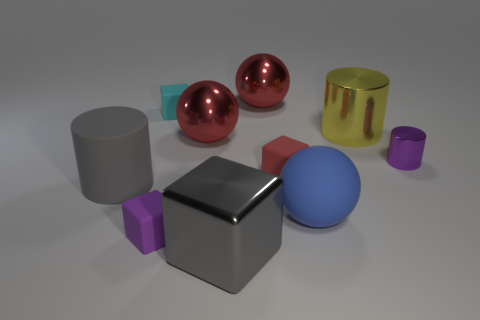Subtract all red rubber blocks. How many blocks are left? 3 Subtract all red cubes. How many cubes are left? 3 Subtract all blue cubes. Subtract all cyan cylinders. How many cubes are left? 4 Subtract all cubes. How many objects are left? 6 Subtract 0 green cylinders. How many objects are left? 10 Subtract all purple matte cubes. Subtract all big gray cylinders. How many objects are left? 8 Add 1 large things. How many large things are left? 7 Add 9 purple matte blocks. How many purple matte blocks exist? 10 